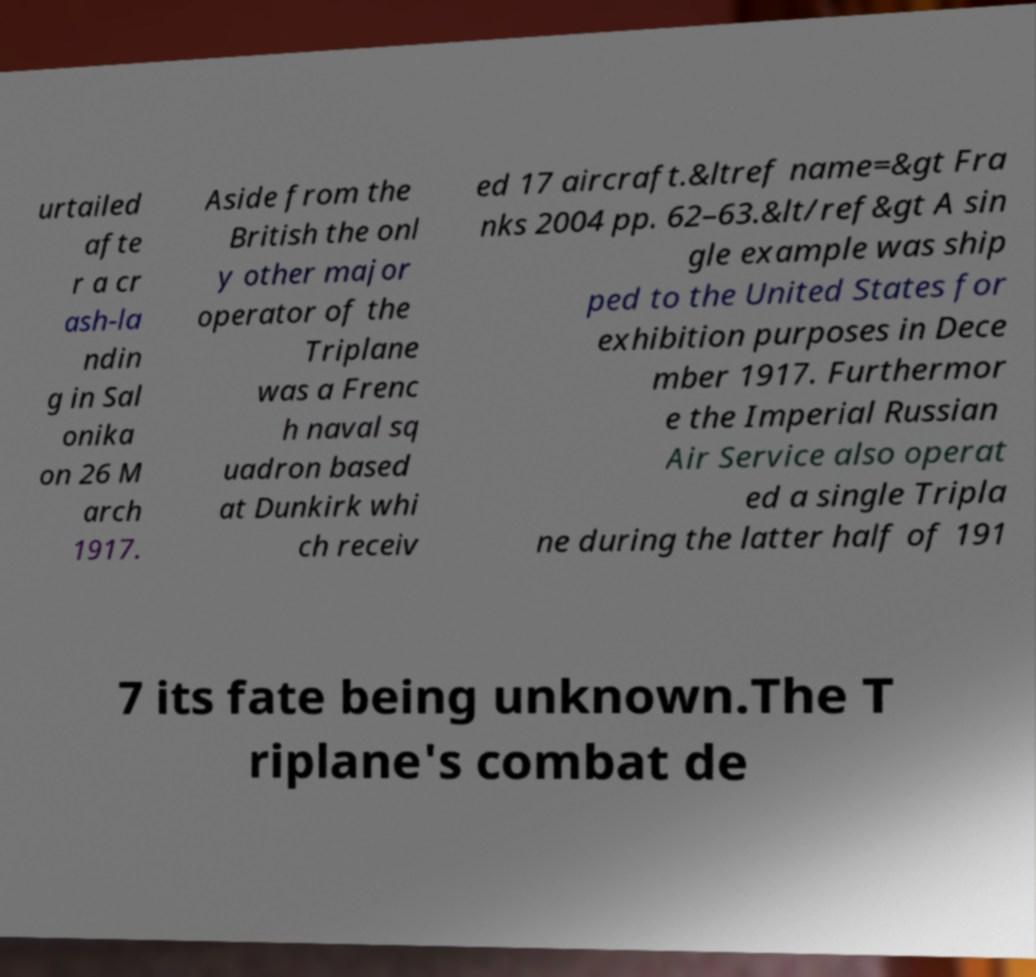Please read and relay the text visible in this image. What does it say? urtailed afte r a cr ash-la ndin g in Sal onika on 26 M arch 1917. Aside from the British the onl y other major operator of the Triplane was a Frenc h naval sq uadron based at Dunkirk whi ch receiv ed 17 aircraft.&ltref name=&gt Fra nks 2004 pp. 62–63.&lt/ref&gt A sin gle example was ship ped to the United States for exhibition purposes in Dece mber 1917. Furthermor e the Imperial Russian Air Service also operat ed a single Tripla ne during the latter half of 191 7 its fate being unknown.The T riplane's combat de 